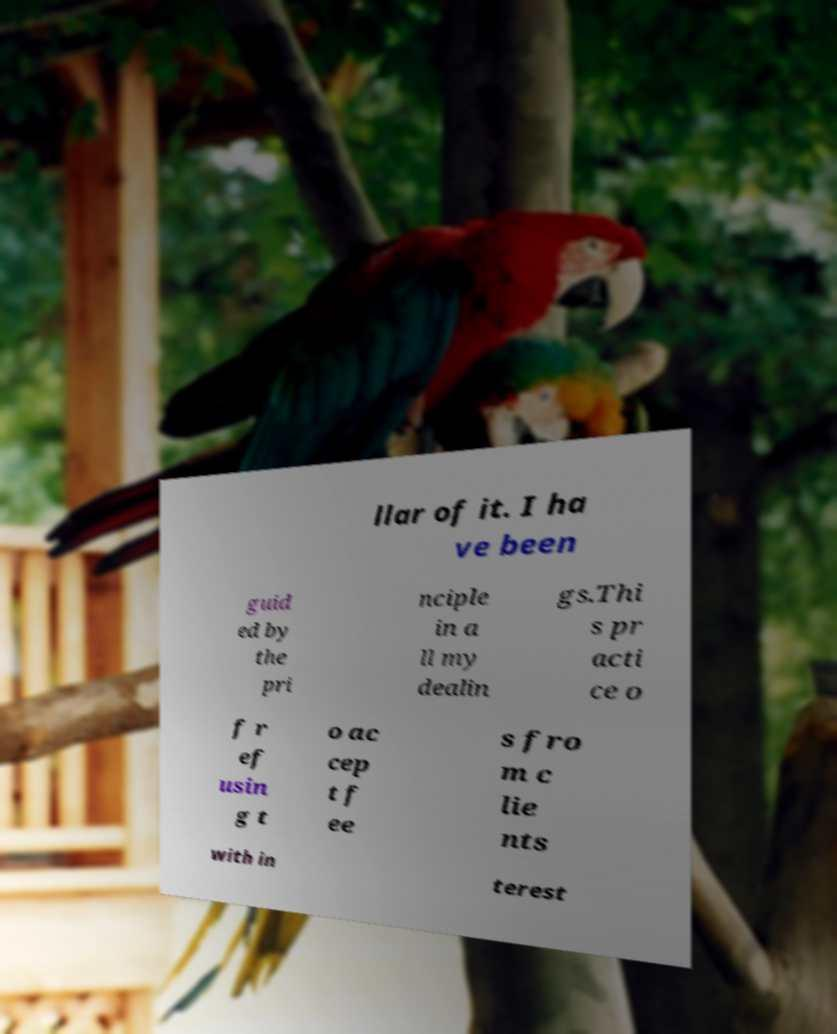There's text embedded in this image that I need extracted. Can you transcribe it verbatim? llar of it. I ha ve been guid ed by the pri nciple in a ll my dealin gs.Thi s pr acti ce o f r ef usin g t o ac cep t f ee s fro m c lie nts with in terest 